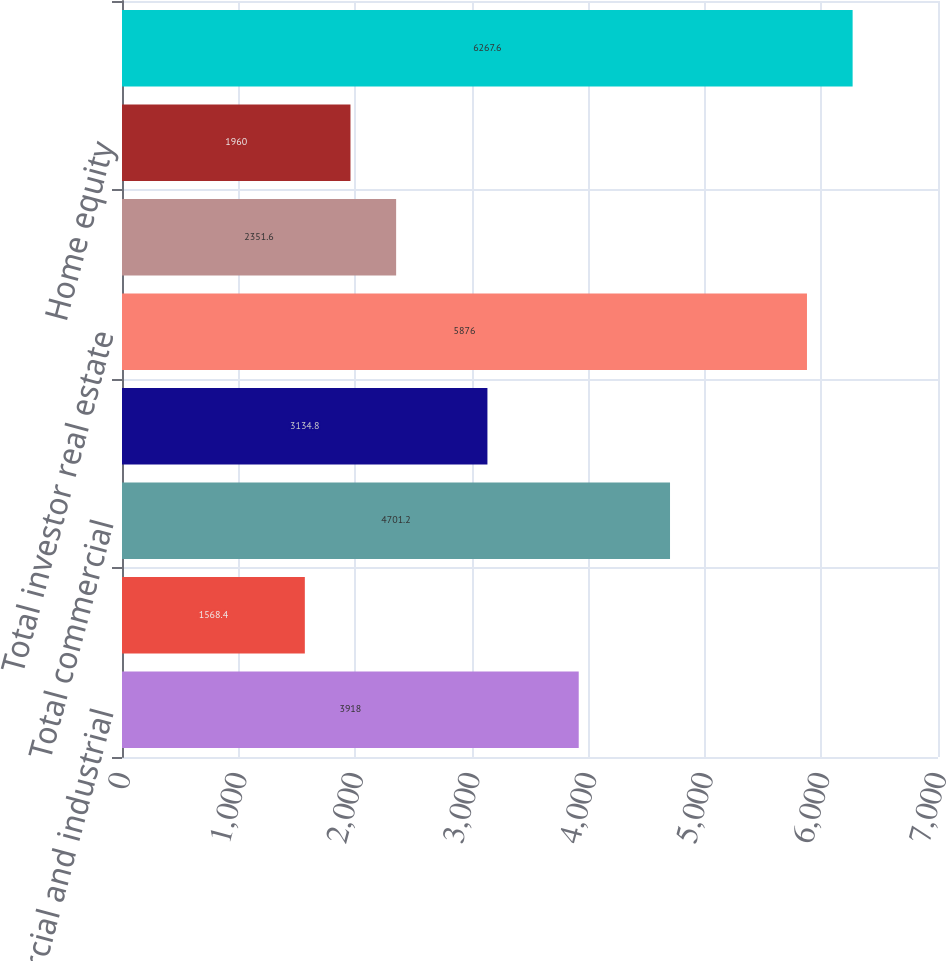Convert chart. <chart><loc_0><loc_0><loc_500><loc_500><bar_chart><fcel>Commercial and industrial<fcel>Commercial real estate<fcel>Total commercial<fcel>Commercial investor real<fcel>Total investor real estate<fcel>Residential first mortgage<fcel>Home equity<fcel>Total non-performing loans<nl><fcel>3918<fcel>1568.4<fcel>4701.2<fcel>3134.8<fcel>5876<fcel>2351.6<fcel>1960<fcel>6267.6<nl></chart> 